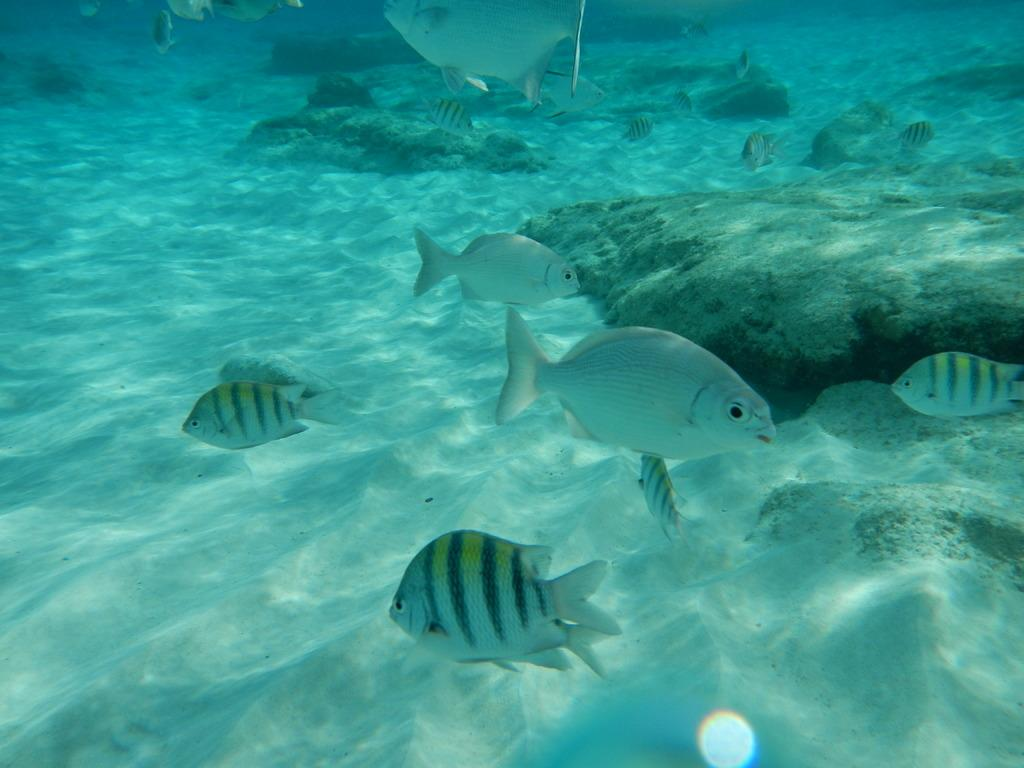What type of animals can be seen in the image? There are fishes in the image. What other elements can be seen in the image besides the fishes? There are stones and sand in the image. Are all of these elements located in the same environment? Yes, all of these elements are under the water. What type of print can be seen on the fishes in the image? There is no print visible on the fishes in the image. Can you describe the spark emitted by the stones in the image? There is no spark emitted by the stones in the image; they are underwater and not producing any light. 